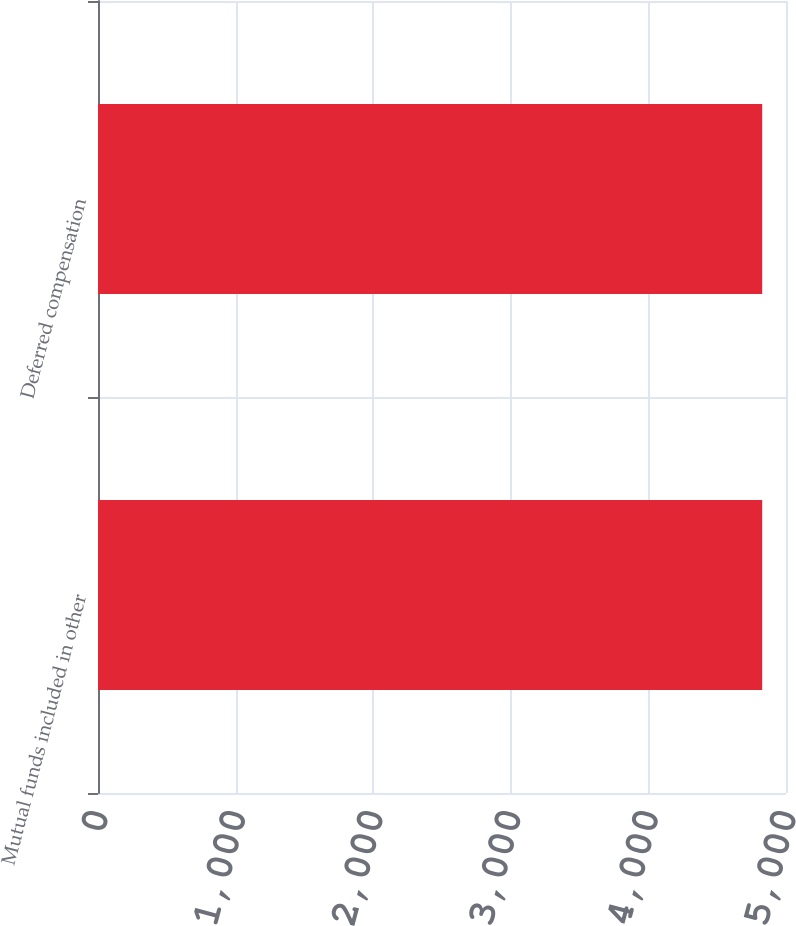Convert chart to OTSL. <chart><loc_0><loc_0><loc_500><loc_500><bar_chart><fcel>Mutual funds included in other<fcel>Deferred compensation<nl><fcel>4827<fcel>4827.1<nl></chart> 